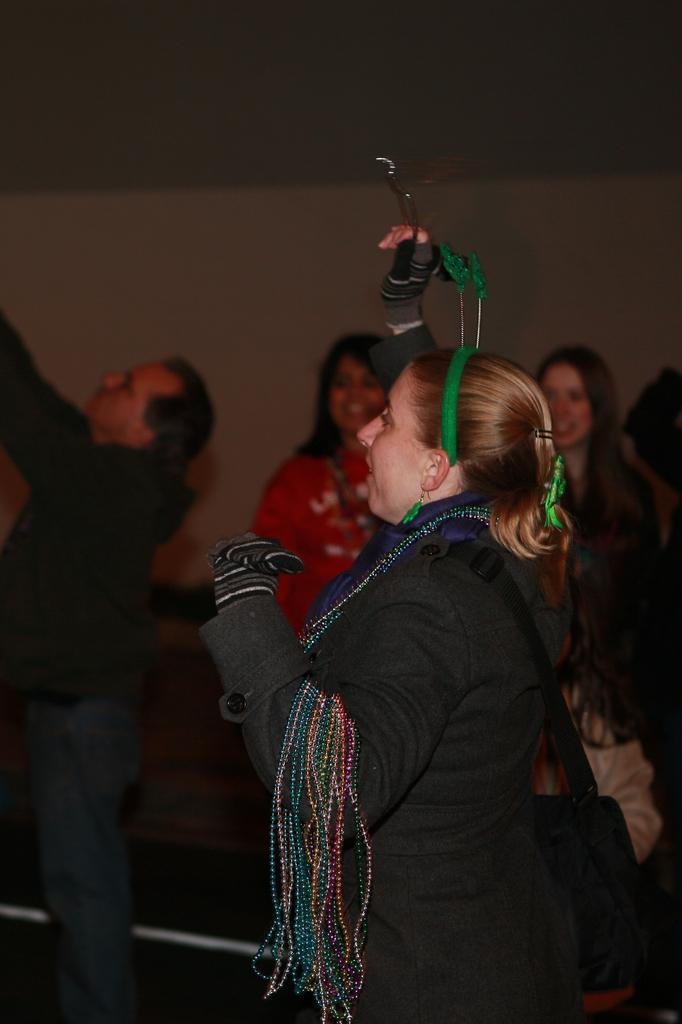Who is the main subject in the image? There is a woman in the image. What is the woman doing in the image? The woman is standing in the image. What is the woman holding in her hand? The woman is holding something in her hand, but we cannot determine what it is from the image. What accessory is the woman wearing? The woman is wearing a handbag. What type of hair is the laborer wearing in the image? There is no laborer present in the image, and the woman's hair is not mentioned in the provided facts. --- 